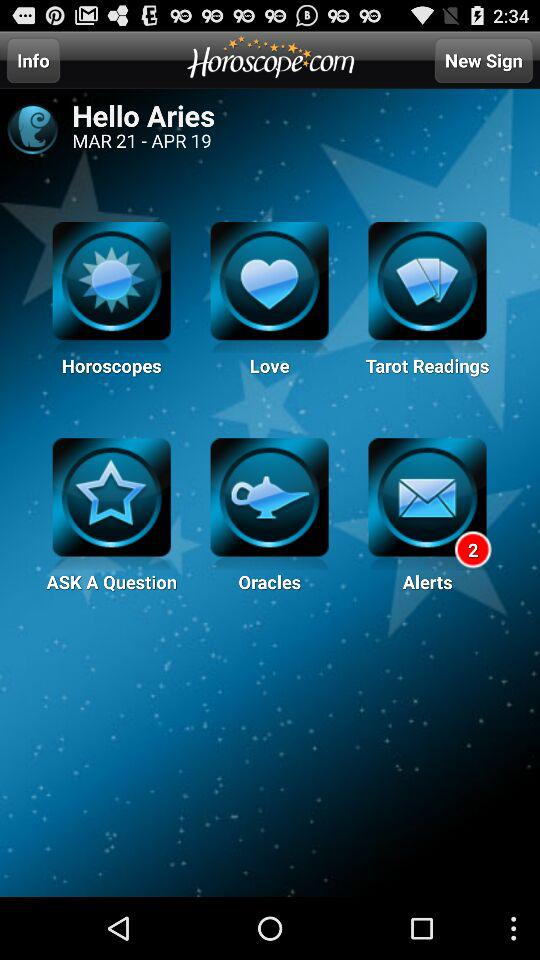How many unread messages are there? There are 2 unread messages. 